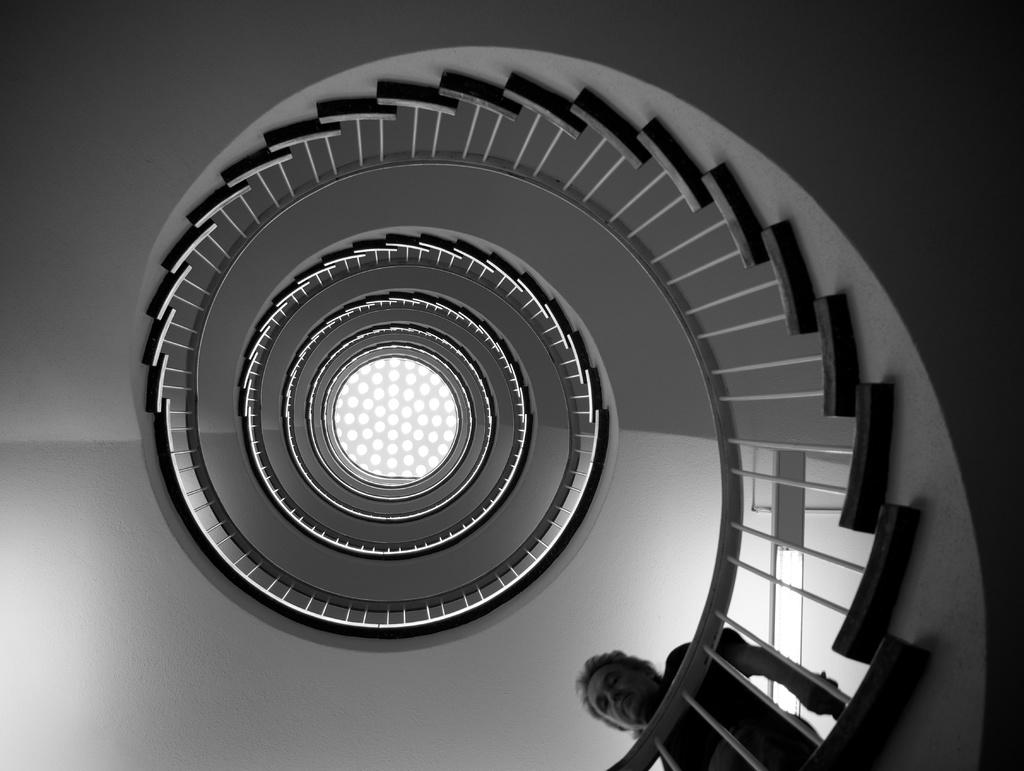What is the color scheme of the image? The image is black and white. What is the man in the image doing? The man is walking in the image. Where is the man walking in the image? The man is walking downstairs. What is visible on top of the building in the image? There is a roof visible in the image, and lights are on the roof. How many chickens are running on the side of the building in the image? There are no chickens present in the image, and they are not running on the side of the building. 